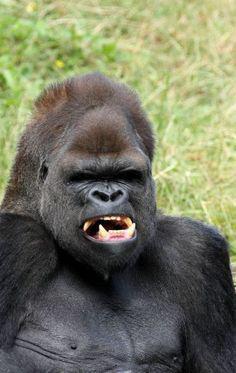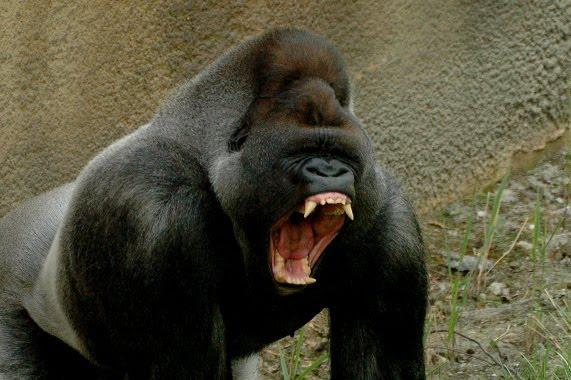The first image is the image on the left, the second image is the image on the right. For the images displayed, is the sentence "Each image features exactly one gorilla, a fierce-looking adult male." factually correct? Answer yes or no. Yes. The first image is the image on the left, the second image is the image on the right. Evaluate the accuracy of this statement regarding the images: "At least one of the images show a baby gorilla". Is it true? Answer yes or no. No. 